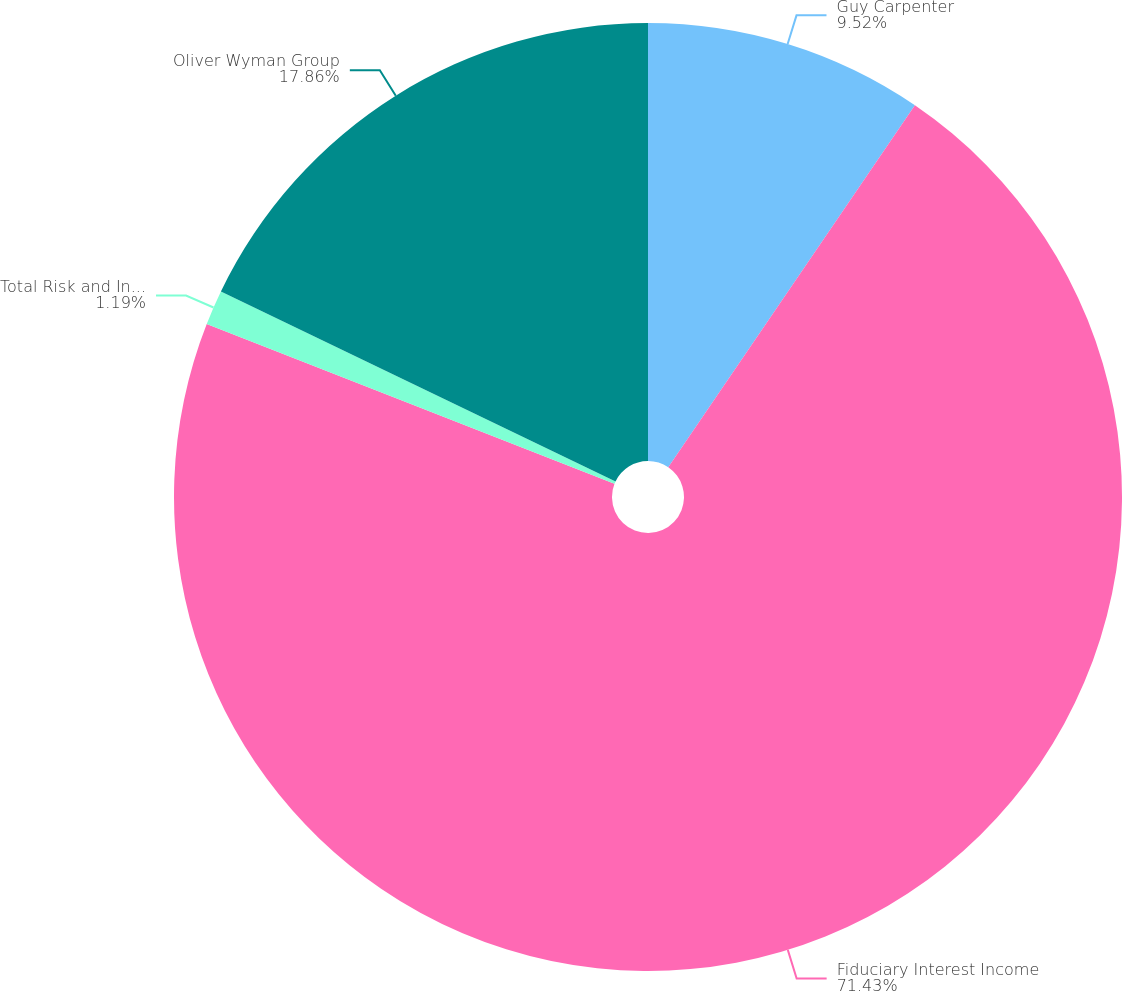Convert chart to OTSL. <chart><loc_0><loc_0><loc_500><loc_500><pie_chart><fcel>Guy Carpenter<fcel>Fiduciary Interest Income<fcel>Total Risk and Insurance<fcel>Oliver Wyman Group<nl><fcel>9.52%<fcel>71.43%<fcel>1.19%<fcel>17.86%<nl></chart> 